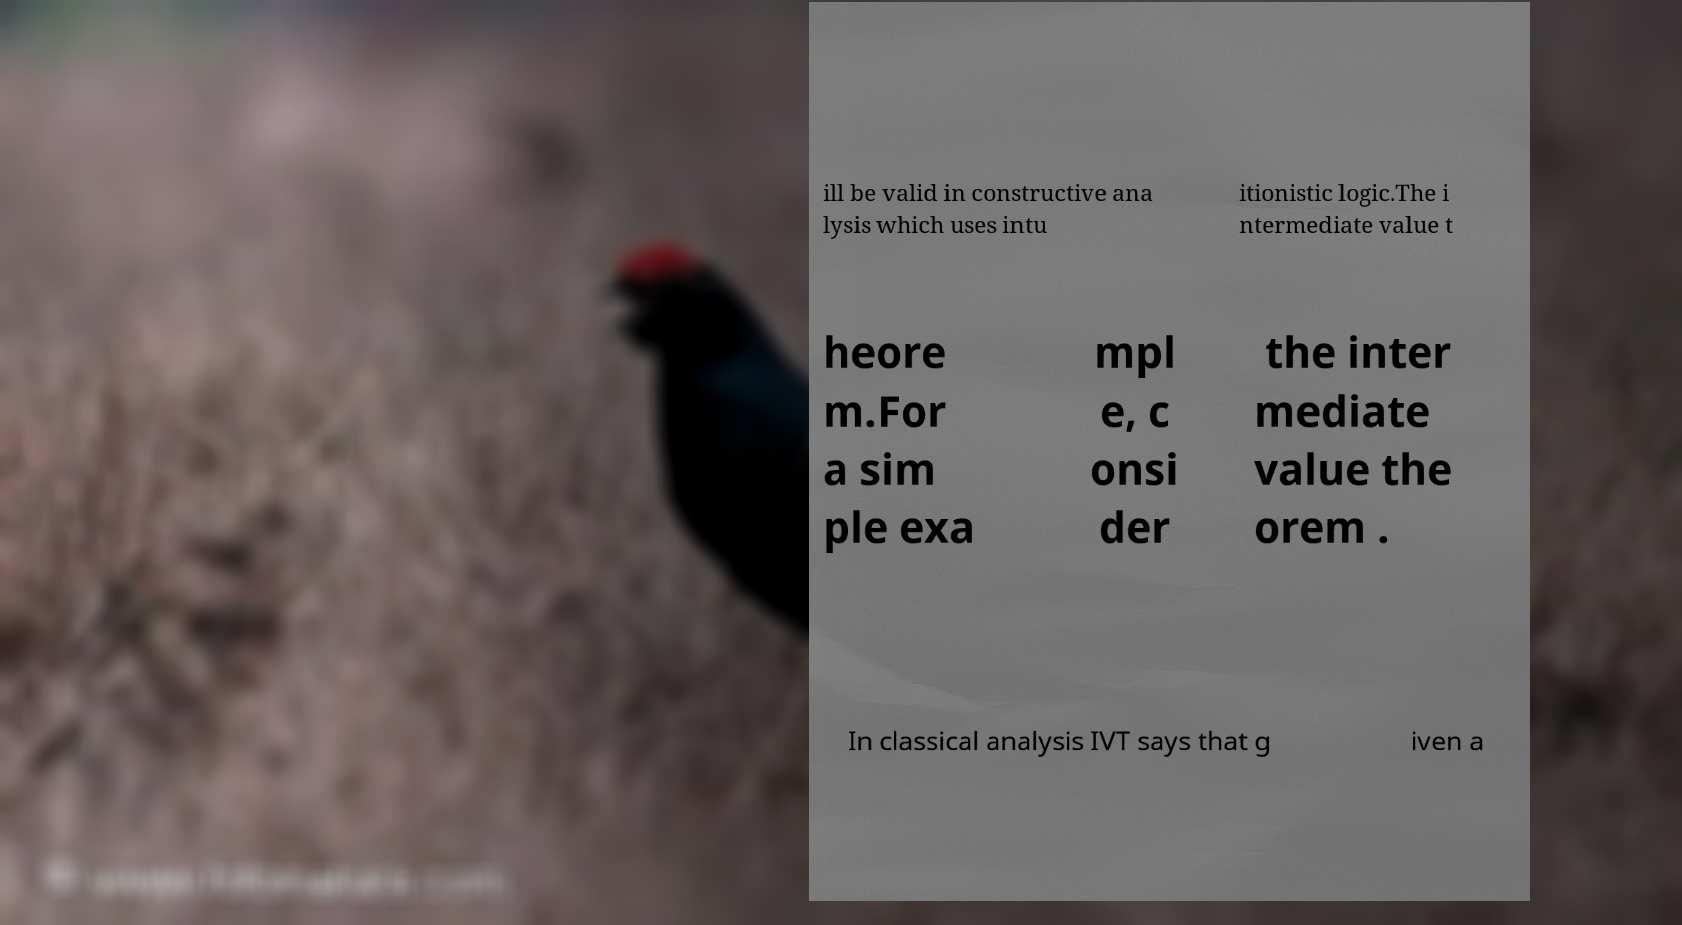Please identify and transcribe the text found in this image. ill be valid in constructive ana lysis which uses intu itionistic logic.The i ntermediate value t heore m.For a sim ple exa mpl e, c onsi der the inter mediate value the orem . In classical analysis IVT says that g iven a 